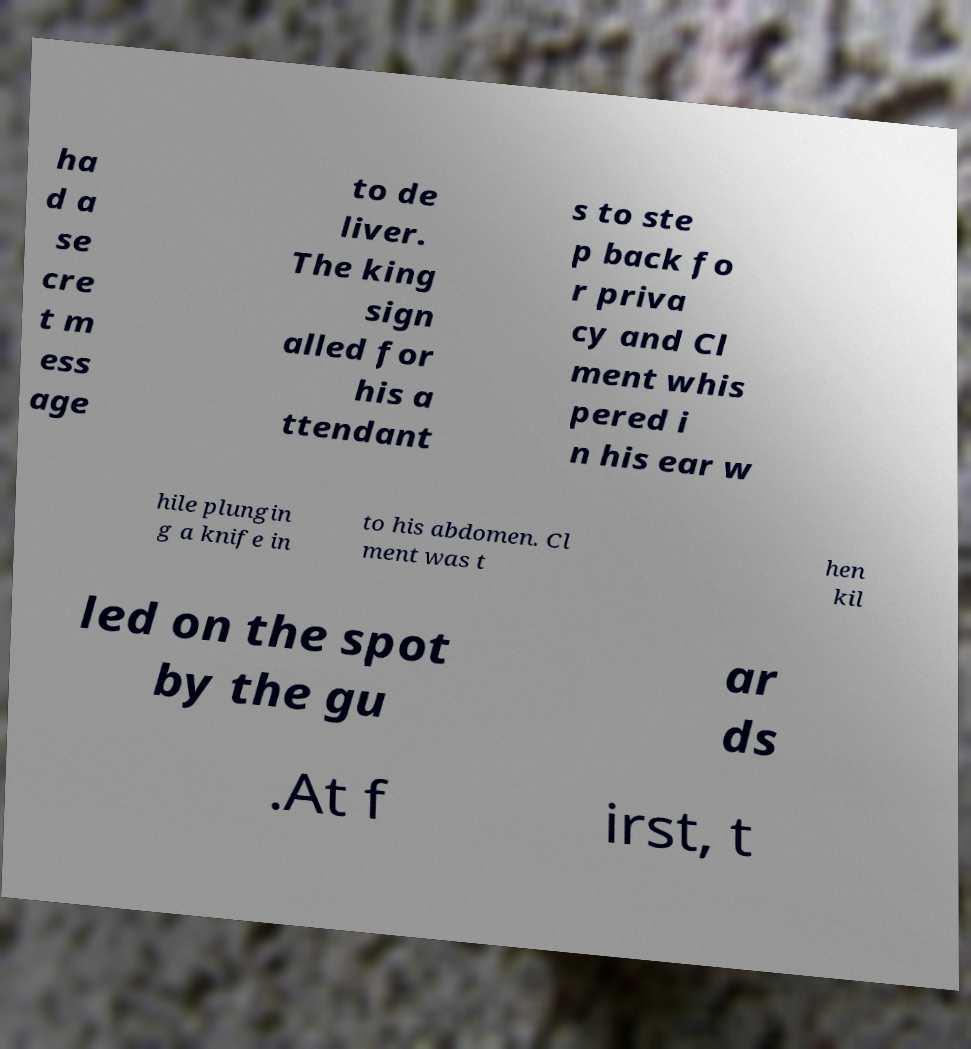Could you extract and type out the text from this image? ha d a se cre t m ess age to de liver. The king sign alled for his a ttendant s to ste p back fo r priva cy and Cl ment whis pered i n his ear w hile plungin g a knife in to his abdomen. Cl ment was t hen kil led on the spot by the gu ar ds .At f irst, t 